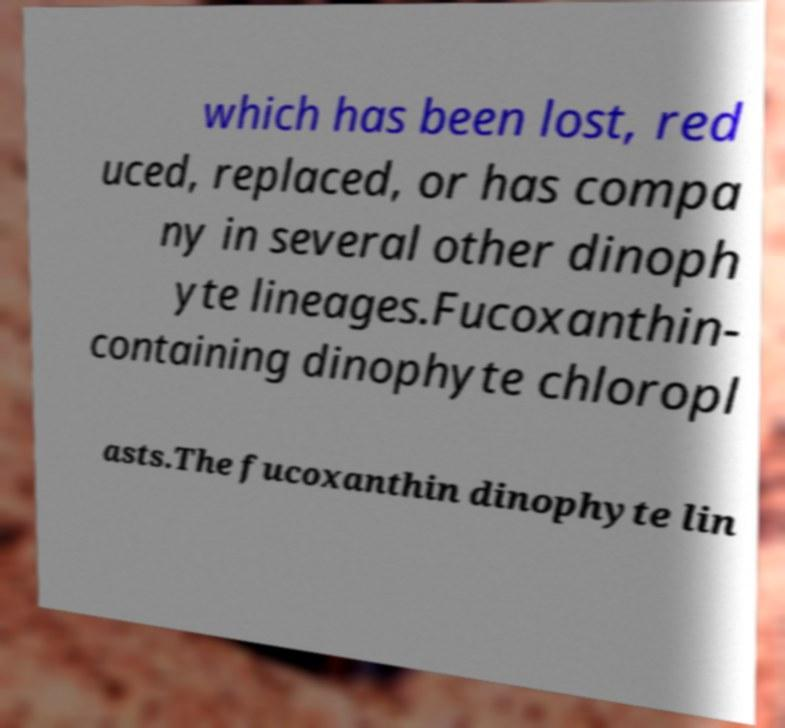Please read and relay the text visible in this image. What does it say? which has been lost, red uced, replaced, or has compa ny in several other dinoph yte lineages.Fucoxanthin- containing dinophyte chloropl asts.The fucoxanthin dinophyte lin 